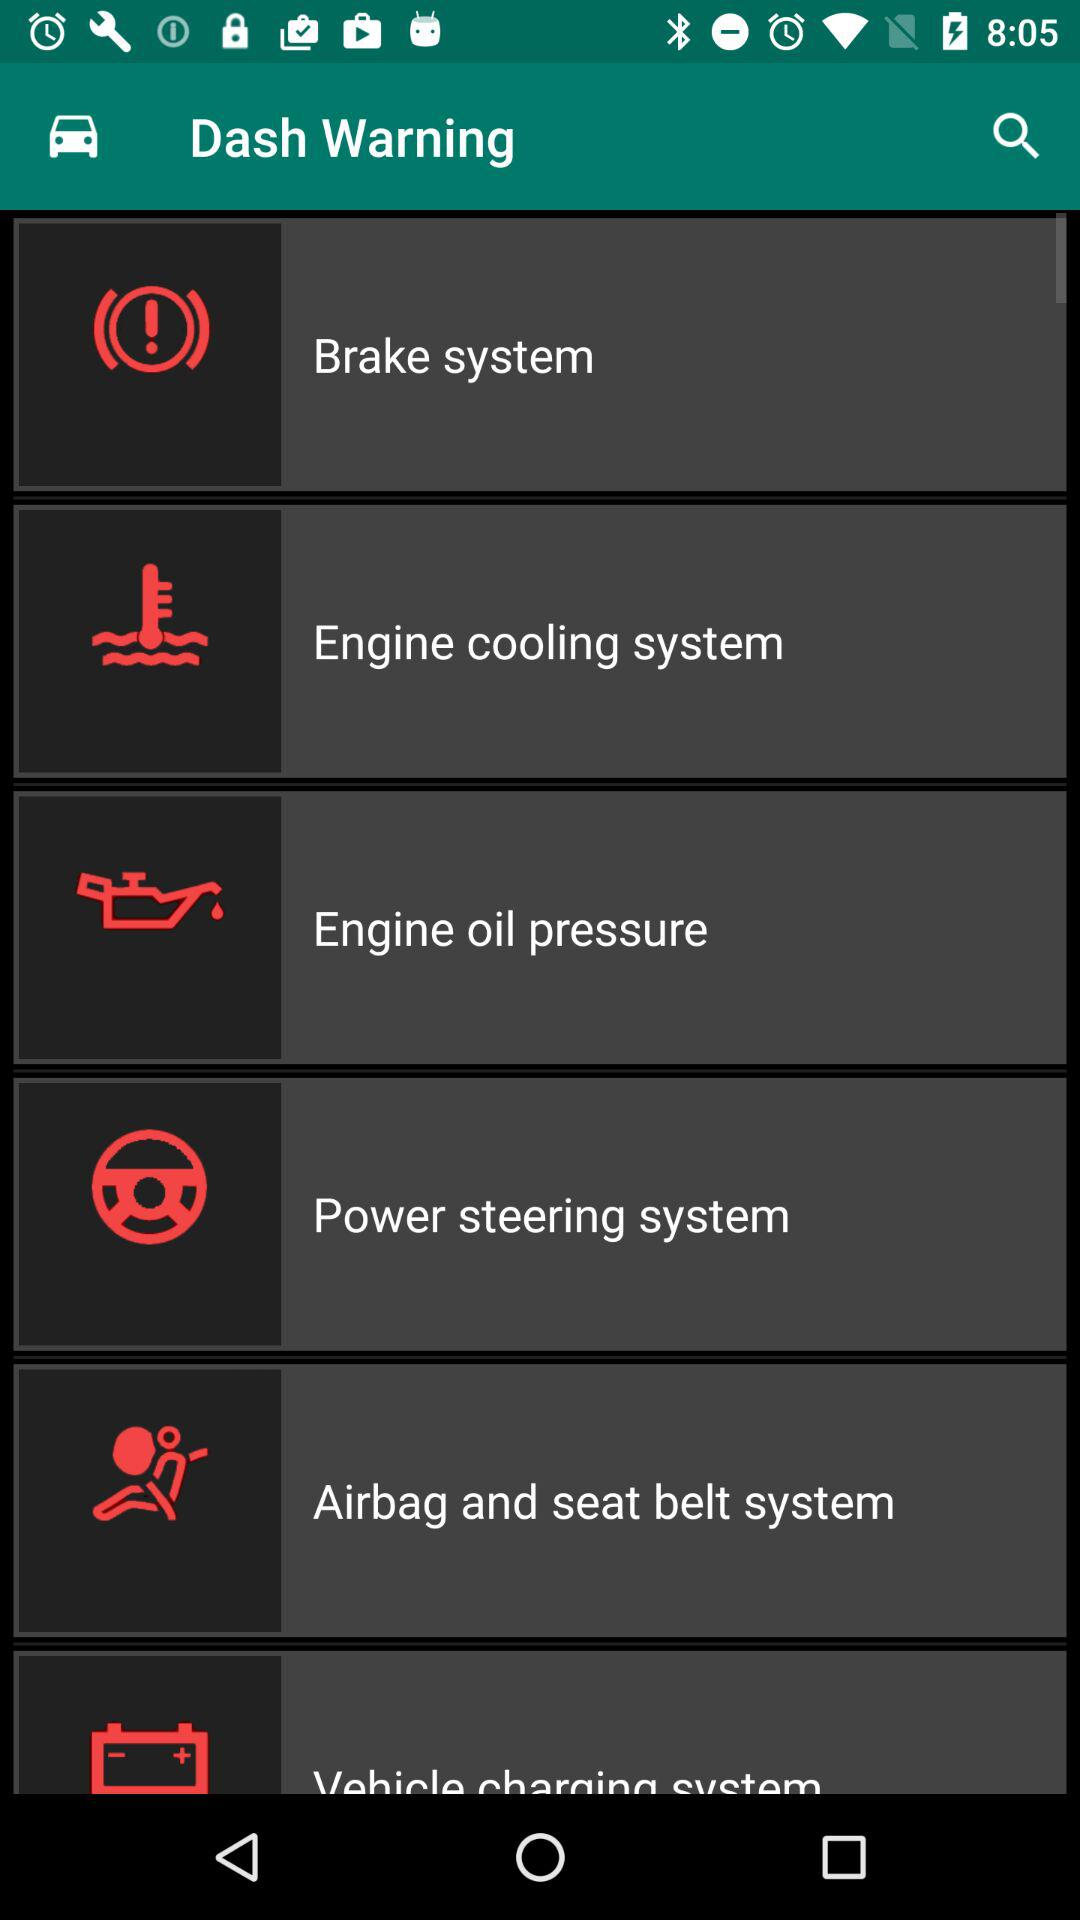How many more warning lights are there for the engine than the brakes?
Answer the question using a single word or phrase. 2 